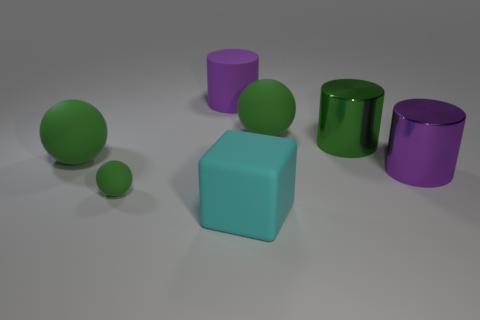Are there the same number of matte balls that are behind the tiny green matte thing and big green spheres that are left of the big purple rubber cylinder?
Make the answer very short. No. What size is the green matte sphere in front of the object to the left of the small sphere?
Provide a short and direct response. Small. The large thing that is on the left side of the cyan block and in front of the purple matte cylinder is made of what material?
Your answer should be compact. Rubber. How many other things are the same size as the green shiny object?
Offer a terse response. 5. The matte cylinder has what color?
Your answer should be very brief. Purple. Do the large cylinder that is on the right side of the green shiny thing and the large sphere that is to the left of the large purple matte cylinder have the same color?
Give a very brief answer. No. How big is the green cylinder?
Give a very brief answer. Large. There is a matte sphere to the right of the small rubber sphere; what size is it?
Ensure brevity in your answer.  Large. The green thing that is behind the small thing and on the left side of the cyan thing has what shape?
Your answer should be very brief. Sphere. What number of other things are the same shape as the large cyan object?
Offer a very short reply. 0. 